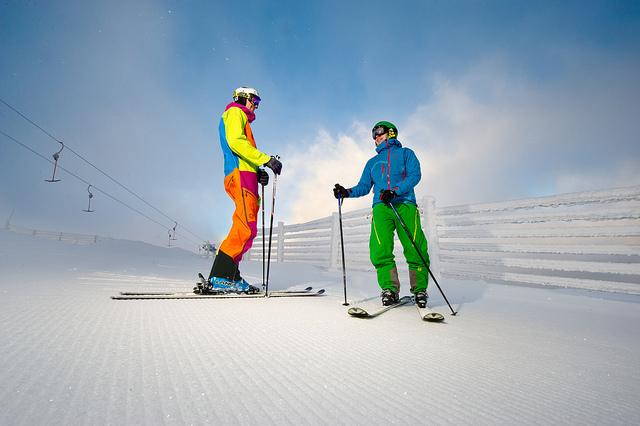Who has the more colorful outfit?
Write a very short answer. Man on left. How many skies are there?
Keep it brief. 4. Is the day sunny?
Quick response, please. Yes. What is on the people's feet?
Quick response, please. Skis. 